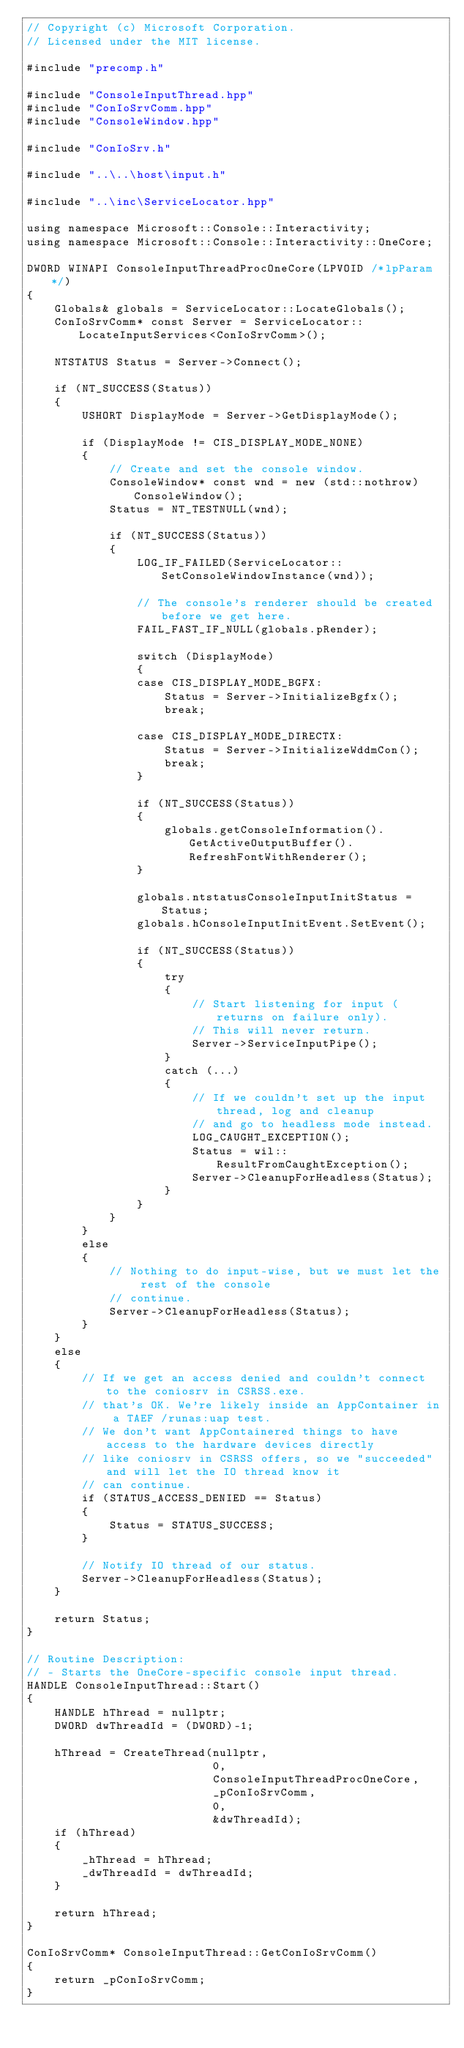Convert code to text. <code><loc_0><loc_0><loc_500><loc_500><_C++_>// Copyright (c) Microsoft Corporation.
// Licensed under the MIT license.

#include "precomp.h"

#include "ConsoleInputThread.hpp"
#include "ConIoSrvComm.hpp"
#include "ConsoleWindow.hpp"

#include "ConIoSrv.h"

#include "..\..\host\input.h"

#include "..\inc\ServiceLocator.hpp"

using namespace Microsoft::Console::Interactivity;
using namespace Microsoft::Console::Interactivity::OneCore;

DWORD WINAPI ConsoleInputThreadProcOneCore(LPVOID /*lpParam*/)
{
    Globals& globals = ServiceLocator::LocateGlobals();
    ConIoSrvComm* const Server = ServiceLocator::LocateInputServices<ConIoSrvComm>();

    NTSTATUS Status = Server->Connect();

    if (NT_SUCCESS(Status))
    {
        USHORT DisplayMode = Server->GetDisplayMode();

        if (DisplayMode != CIS_DISPLAY_MODE_NONE)
        {
            // Create and set the console window.
            ConsoleWindow* const wnd = new (std::nothrow) ConsoleWindow();
            Status = NT_TESTNULL(wnd);

            if (NT_SUCCESS(Status))
            {
                LOG_IF_FAILED(ServiceLocator::SetConsoleWindowInstance(wnd));

                // The console's renderer should be created before we get here.
                FAIL_FAST_IF_NULL(globals.pRender);

                switch (DisplayMode)
                {
                case CIS_DISPLAY_MODE_BGFX:
                    Status = Server->InitializeBgfx();
                    break;

                case CIS_DISPLAY_MODE_DIRECTX:
                    Status = Server->InitializeWddmCon();
                    break;
                }

                if (NT_SUCCESS(Status))
                {
                    globals.getConsoleInformation().GetActiveOutputBuffer().RefreshFontWithRenderer();
                }

                globals.ntstatusConsoleInputInitStatus = Status;
                globals.hConsoleInputInitEvent.SetEvent();

                if (NT_SUCCESS(Status))
                {
                    try
                    {
                        // Start listening for input (returns on failure only).
                        // This will never return.
                        Server->ServiceInputPipe();
                    }
                    catch (...)
                    {
                        // If we couldn't set up the input thread, log and cleanup
                        // and go to headless mode instead.
                        LOG_CAUGHT_EXCEPTION();
                        Status = wil::ResultFromCaughtException();
                        Server->CleanupForHeadless(Status);
                    }
                }
            }
        }
        else
        {
            // Nothing to do input-wise, but we must let the rest of the console
            // continue.
            Server->CleanupForHeadless(Status);
        }
    }
    else
    {
        // If we get an access denied and couldn't connect to the coniosrv in CSRSS.exe.
        // that's OK. We're likely inside an AppContainer in a TAEF /runas:uap test.
        // We don't want AppContainered things to have access to the hardware devices directly
        // like coniosrv in CSRSS offers, so we "succeeded" and will let the IO thread know it
        // can continue.
        if (STATUS_ACCESS_DENIED == Status)
        {
            Status = STATUS_SUCCESS;
        }

        // Notify IO thread of our status.
        Server->CleanupForHeadless(Status);
    }

    return Status;
}

// Routine Description:
// - Starts the OneCore-specific console input thread.
HANDLE ConsoleInputThread::Start()
{
    HANDLE hThread = nullptr;
    DWORD dwThreadId = (DWORD)-1;

    hThread = CreateThread(nullptr,
                           0,
                           ConsoleInputThreadProcOneCore,
                           _pConIoSrvComm,
                           0,
                           &dwThreadId);
    if (hThread)
    {
        _hThread = hThread;
        _dwThreadId = dwThreadId;
    }

    return hThread;
}

ConIoSrvComm* ConsoleInputThread::GetConIoSrvComm()
{
    return _pConIoSrvComm;
}
</code> 